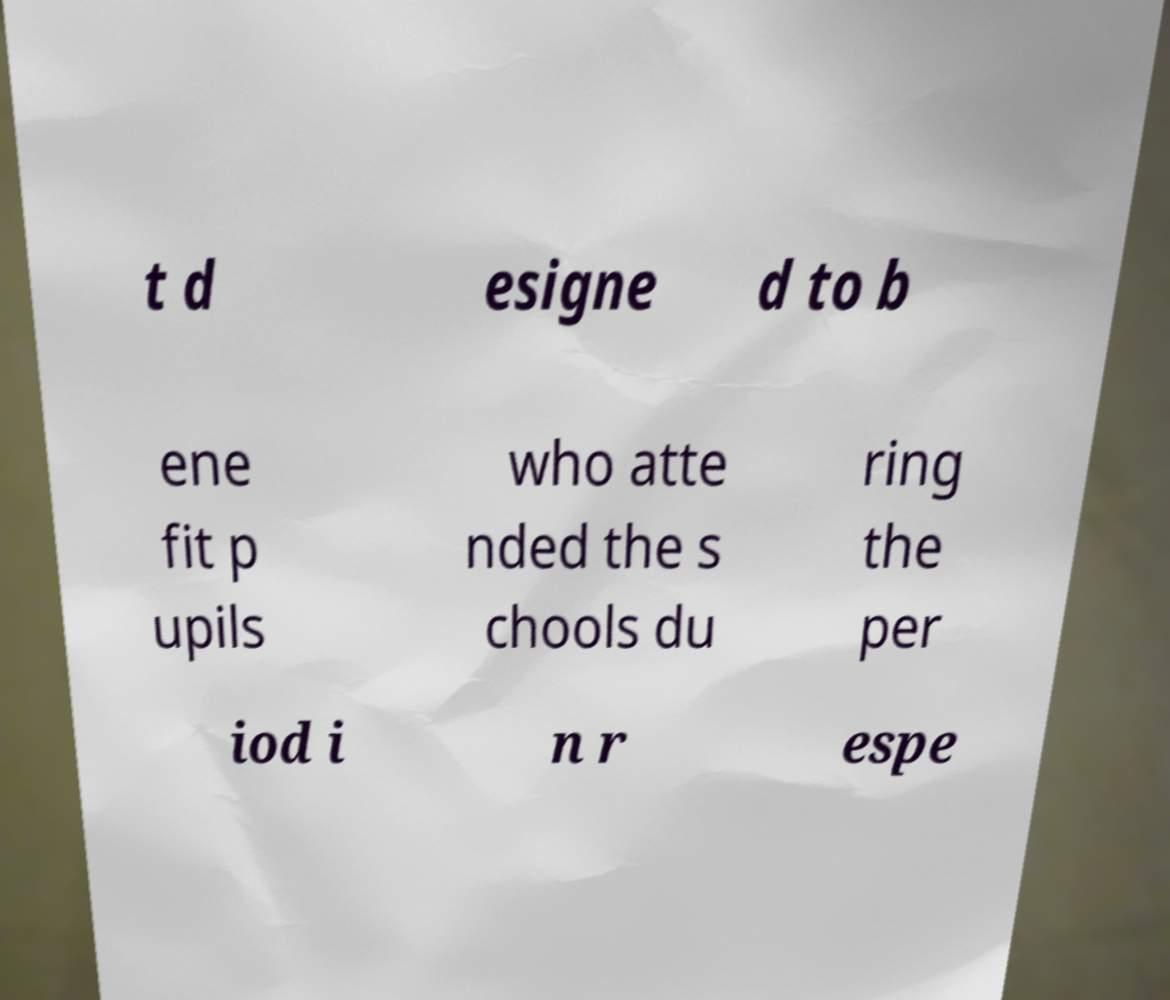Please identify and transcribe the text found in this image. t d esigne d to b ene fit p upils who atte nded the s chools du ring the per iod i n r espe 